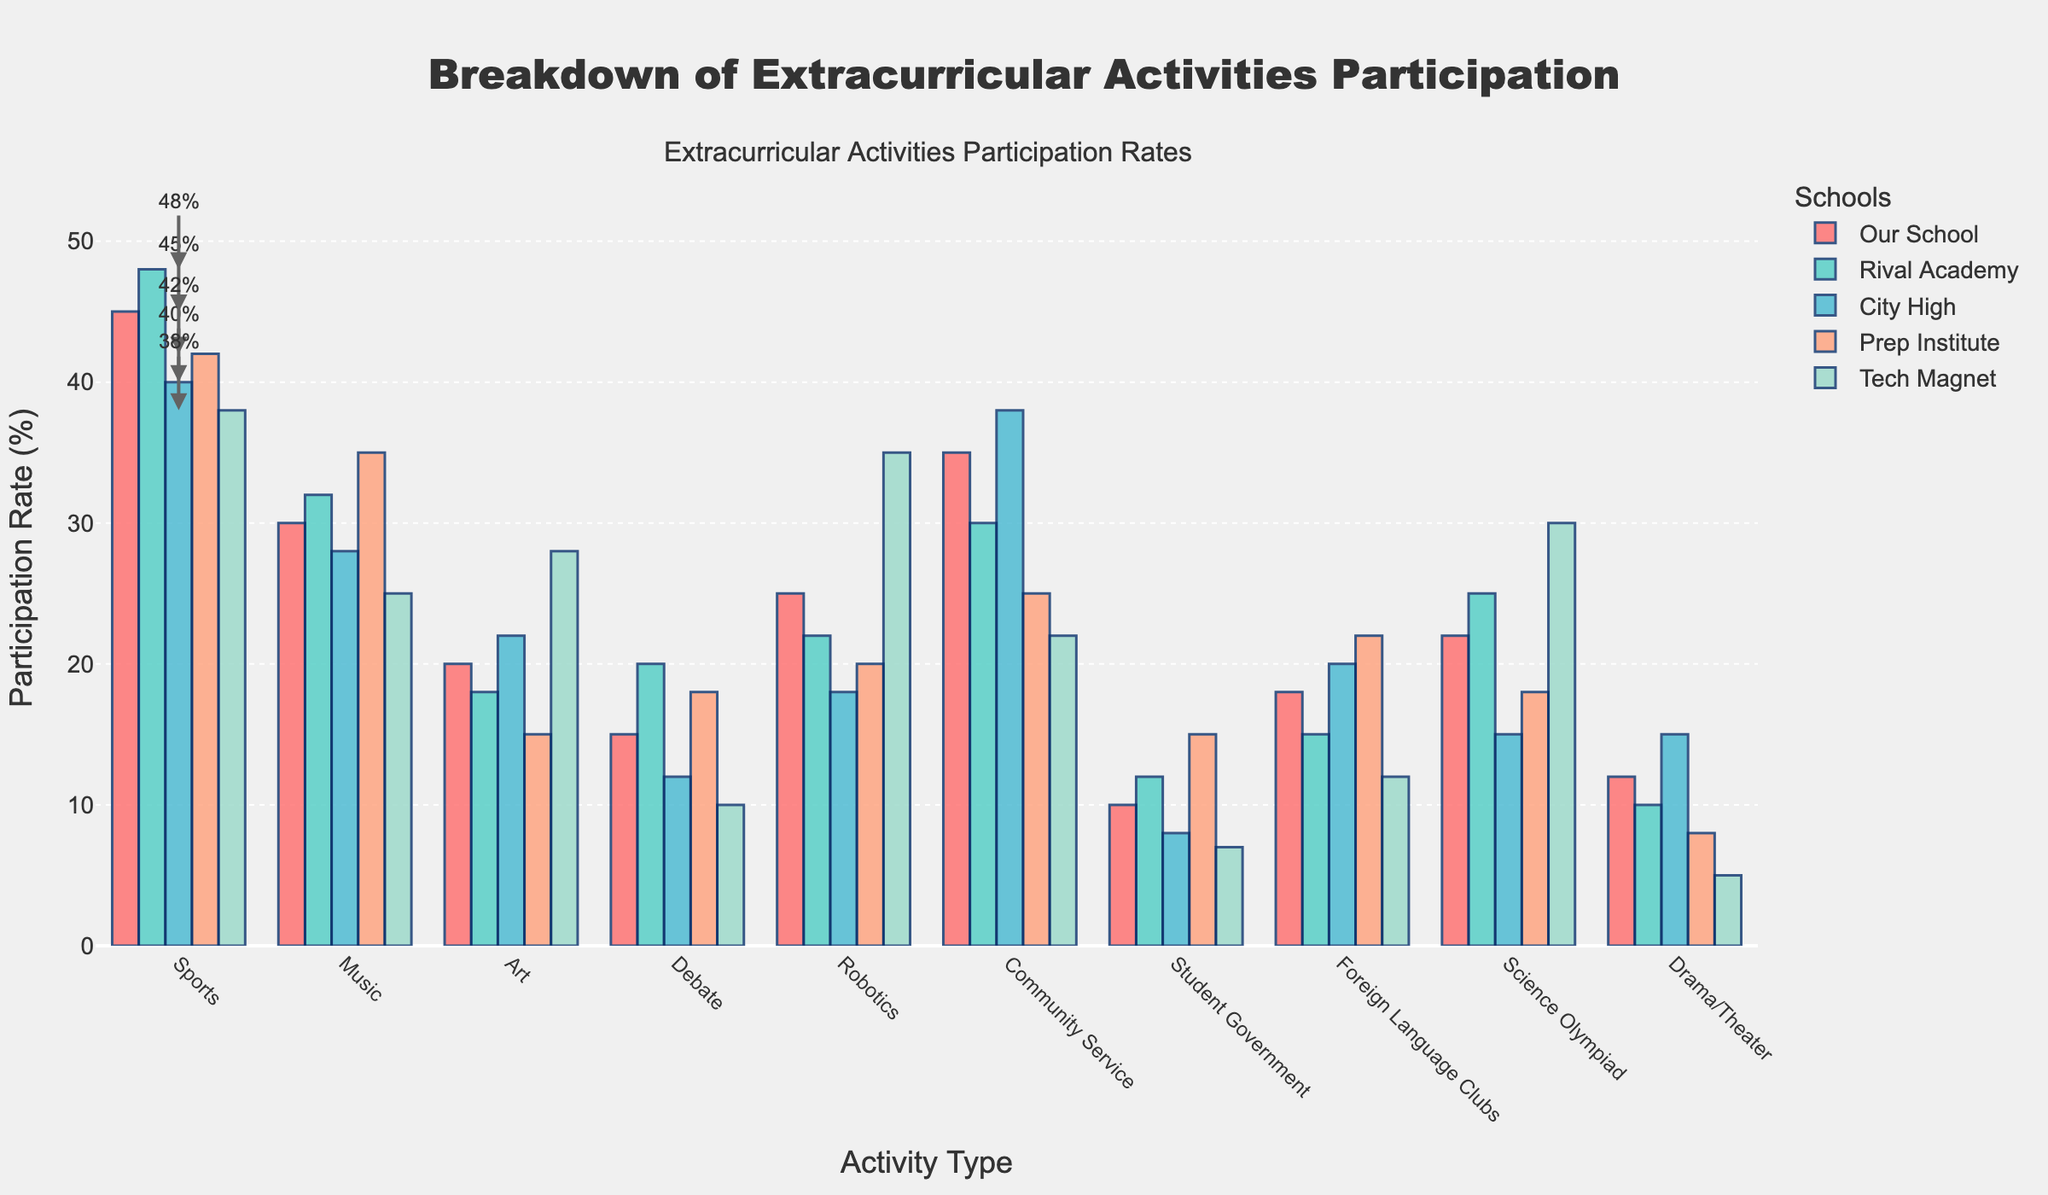what is the participation rate for Sports in our school? By looking at the figure, find the bar representing "Sports" for "Our School" and note the value.
Answer: 45% Which school has the highest participation rate in Music? Look at the values of the bars labeled "Music" for all schools. The highest bar is the one with the highest participation rate.
Answer: Prep Institute How much higher is the participation rate for Robotics in Tech Magnet compared to City High? Find the bar heights for "Robotics" in both "Tech Magnet" and "City High." Subtract City High's rate from Tech Magnet's rate. Tech Magnet's rate is 35%, and City High's rate is 18%. So, 35% - 18% = 17%.
Answer: 17% What's the average participation rate in Community Service across all schools? Sum the participation rates for "Community Service" in all schools: 35 + 30 + 38 + 25 + 22. The total is 150. Divide by the number of schools (5). So, 150 / 5 = 30.
Answer: 30% Which activity has the lowest overall participation rate across all schools? Add up the participation rates for each activity across all schools and compare. Drama/Theater has the lowest participation rate with (12 + 10 + 15 + 8 + 5) = 50.
Answer: Drama/Theater Is the participation rate in Foreign Language Clubs higher in Our School or Prep Institute? Compare the bar heights for "Foreign Language Clubs" in "Our School" and "Prep Institute". Our School has 18%, and Prep Institute has 22%.
Answer: Prep Institute By how much does the participation rate in Science Olympiad for Tech Magnet exceed our school? Look at the bar heights for "Science Olympiad" for both "Tech Magnet" and "Our School." Subtract Our School's rate from Tech Magnet's rate. Tech Magnet's rate is 30%, and Our School's rate is 22%. So, 30% - 22% = 8%.
Answer: 8% Which activity does Rival Academy have the highest participation rate in? Find the highest bar for Rival Academy. The highest bar is "Sports" with 48%.
Answer: Sports Is the participation rate for Debate in City High more than twice that in Tech Magnet? The participation rate for "Debate" in City High is 12%, and in Tech Magnet, it is 10%. Compare City High’s rate (12%) with twice Tech Magnet’s rate (20%). 12% is not more than 20%.
Answer: No 